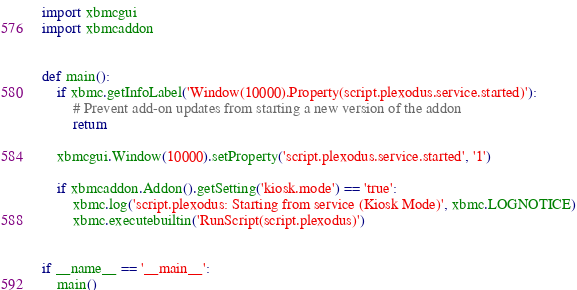<code> <loc_0><loc_0><loc_500><loc_500><_Python_>import xbmcgui
import xbmcaddon


def main():
    if xbmc.getInfoLabel('Window(10000).Property(script.plexodus.service.started)'):
        # Prevent add-on updates from starting a new version of the addon
        return

    xbmcgui.Window(10000).setProperty('script.plexodus.service.started', '1')

    if xbmcaddon.Addon().getSetting('kiosk.mode') == 'true':
        xbmc.log('script.plexodus: Starting from service (Kiosk Mode)', xbmc.LOGNOTICE)
        xbmc.executebuiltin('RunScript(script.plexodus)')


if __name__ == '__main__':
    main()
</code> 